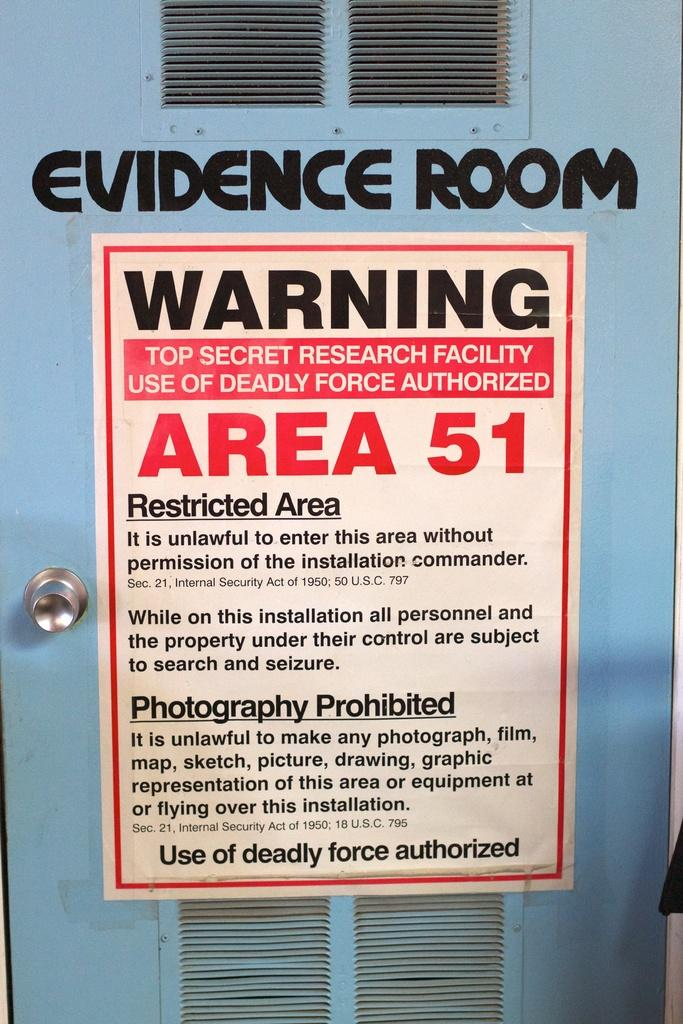Provide a one-sentence caption for the provided image. A door labeled evidence room, with a sign regarding Area 51 on it. 